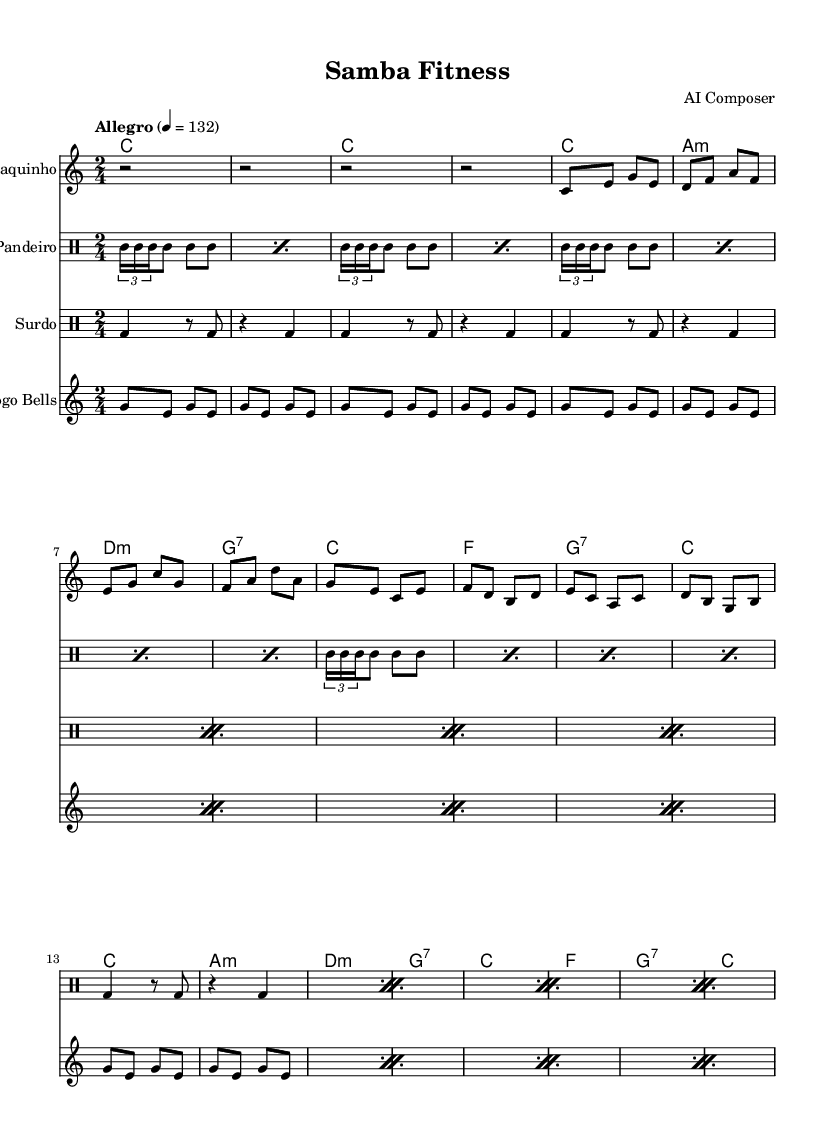What is the key signature of this music? The key signature is C major, which has no sharps or flats indicated at the beginning of the piece. This is identified by the lack of any sharp or flat symbols on the staff lines.
Answer: C major What is the time signature of this music? The time signature is 2/4, which is shown at the beginning of the score. This means there are 2 beats in each measure and a quarter note gets one beat.
Answer: 2/4 What is the tempo marking for this piece? The tempo marking is "Allegro" with a metronome mark of 132 beats per minute. This is indicated in the score above the clef, denoting a fast and lively pace.
Answer: Allegro, 132 What instruments are present in this sheet music? The instruments are Cavaquinho, Pandeiro, Surdo, and Agogo Bells, clearly labeled at the beginning of each staff. This gives a direct identification of the instrumental arrangement.
Answer: Cavaquinho, Pandeiro, Surdo, Agogo Bells How many measures are in the Cavaquinho part? The Cavaquinho part consists of 16 measures; each line in the score typically represents 4 measures, and there are 4 lines in the provided section.
Answer: 16 Which rhythm is predominantly used in the Pandeiro? The Pandeiro rhythm features repeated triplet patterns and steady eighth notes throughout its part, which is characteristic of samba rhythms, and is clear from the notation used.
Answer: Triplet patterns What harmonic progression is used in the chord names? The harmonic progression is C, Am, Dm, G7, repeated throughout the piece. This is indicated in the chord names section and outlines the basic structure of the music.
Answer: C, Am, Dm, G7 